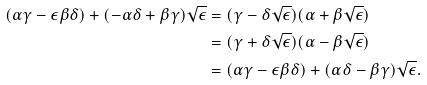<formula> <loc_0><loc_0><loc_500><loc_500>( \alpha \gamma - \epsilon \beta \delta ) + ( - \alpha \delta + \beta \gamma ) \sqrt { \epsilon } & = ( \gamma - \delta \sqrt { \epsilon } ) ( \alpha + \beta \sqrt { \epsilon } ) \\ & = ( \gamma + \delta \sqrt { \epsilon } ) ( \alpha - \beta \sqrt { \epsilon } ) \\ & = ( \alpha \gamma - \epsilon \beta \delta ) + ( \alpha \delta - \beta \gamma ) \sqrt { \epsilon } .</formula> 